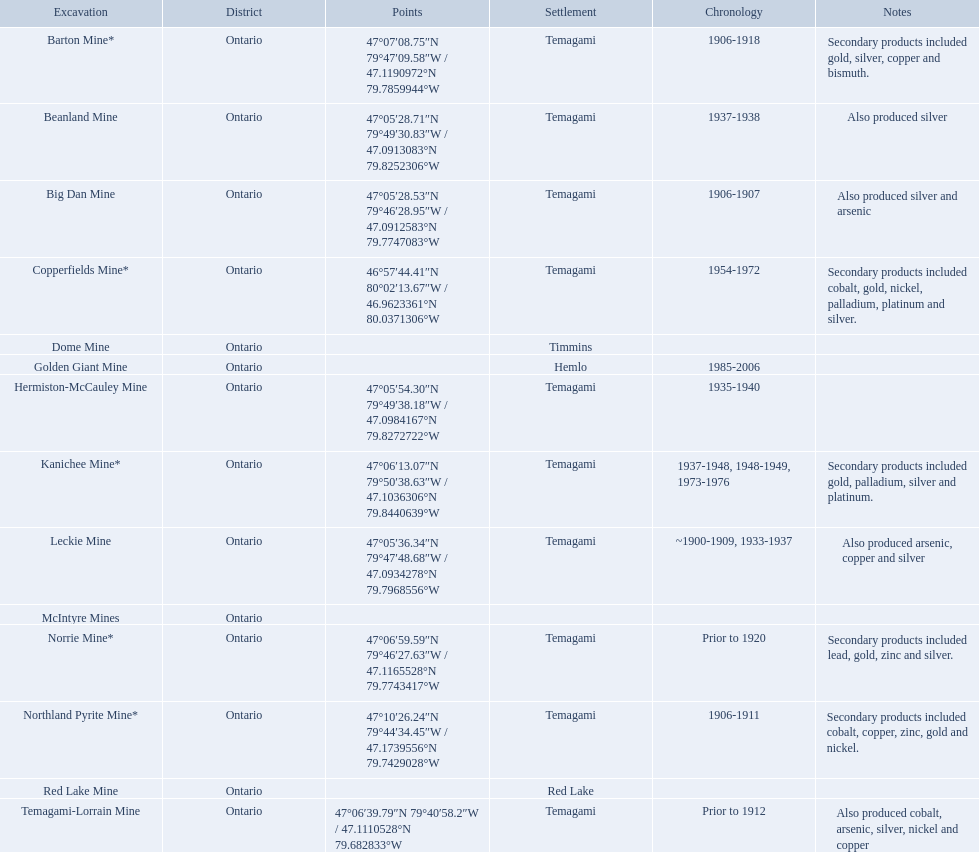What are all the mines with dates listed? Barton Mine*, Beanland Mine, Big Dan Mine, Copperfields Mine*, Golden Giant Mine, Hermiston-McCauley Mine, Kanichee Mine*, Leckie Mine, Norrie Mine*, Northland Pyrite Mine*, Temagami-Lorrain Mine. Which of those dates include the year that the mine was closed? 1906-1918, 1937-1938, 1906-1907, 1954-1972, 1985-2006, 1935-1940, 1937-1948, 1948-1949, 1973-1976, ~1900-1909, 1933-1937, 1906-1911. Which of those mines were opened the longest? Golden Giant Mine. What years was the golden giant mine open for? 1985-2006. What years was the beanland mine open? 1937-1938. Which of these two mines was open longer? Golden Giant Mine. 